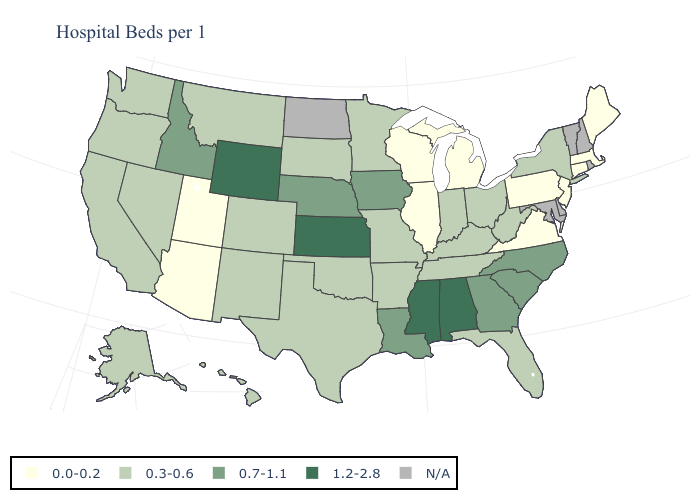Name the states that have a value in the range 0.0-0.2?
Write a very short answer. Arizona, Connecticut, Illinois, Maine, Massachusetts, Michigan, New Jersey, Pennsylvania, Utah, Virginia, Wisconsin. What is the value of Kentucky?
Give a very brief answer. 0.3-0.6. Among the states that border Arizona , which have the highest value?
Give a very brief answer. California, Colorado, Nevada, New Mexico. Does the first symbol in the legend represent the smallest category?
Keep it brief. Yes. What is the value of South Dakota?
Give a very brief answer. 0.3-0.6. Which states hav the highest value in the MidWest?
Keep it brief. Kansas. Does the first symbol in the legend represent the smallest category?
Keep it brief. Yes. What is the lowest value in the USA?
Be succinct. 0.0-0.2. What is the value of Vermont?
Keep it brief. N/A. Among the states that border Vermont , does Massachusetts have the lowest value?
Quick response, please. Yes. What is the value of Mississippi?
Keep it brief. 1.2-2.8. Is the legend a continuous bar?
Quick response, please. No. Does Tennessee have the lowest value in the South?
Concise answer only. No. What is the value of Nebraska?
Quick response, please. 0.7-1.1. What is the value of Mississippi?
Be succinct. 1.2-2.8. 